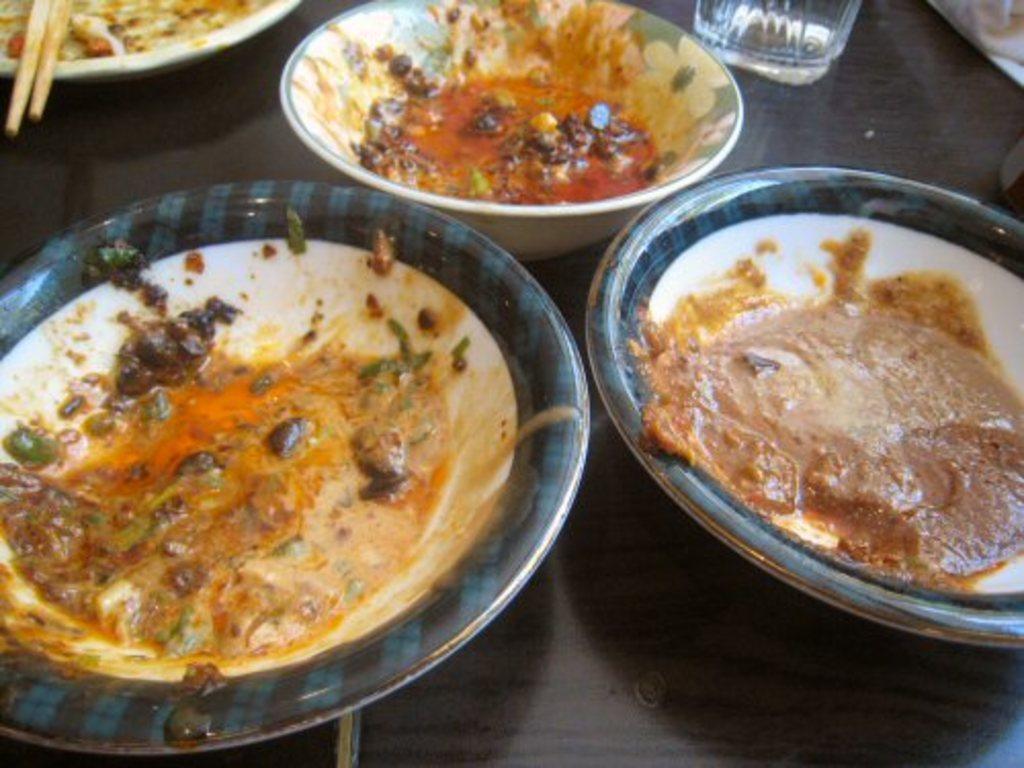In one or two sentences, can you explain what this image depicts? In this image there is a bowl, plates, glass, chopsticks and food on the wooden surface.   